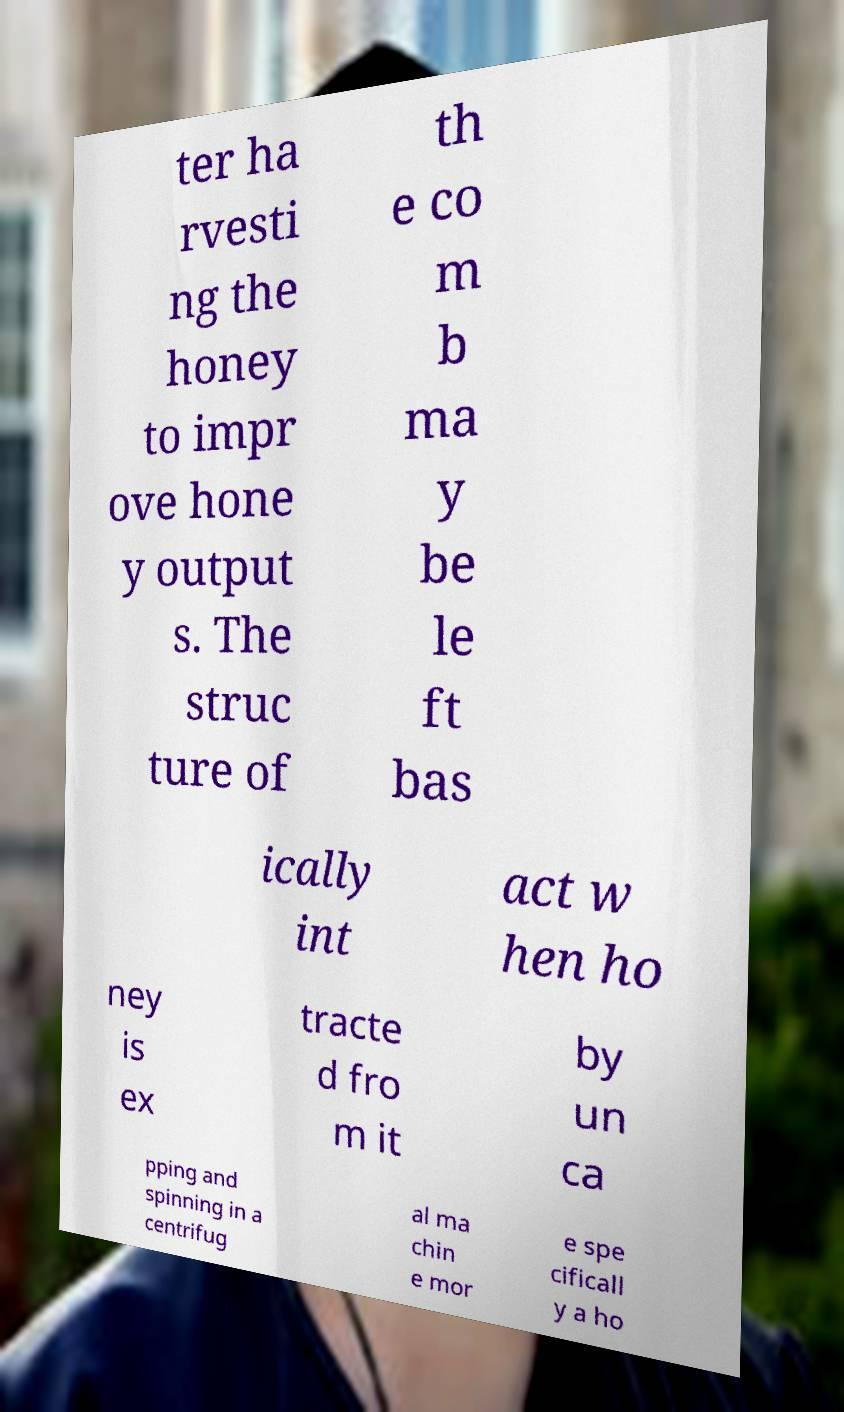Please identify and transcribe the text found in this image. ter ha rvesti ng the honey to impr ove hone y output s. The struc ture of th e co m b ma y be le ft bas ically int act w hen ho ney is ex tracte d fro m it by un ca pping and spinning in a centrifug al ma chin e mor e spe cificall y a ho 